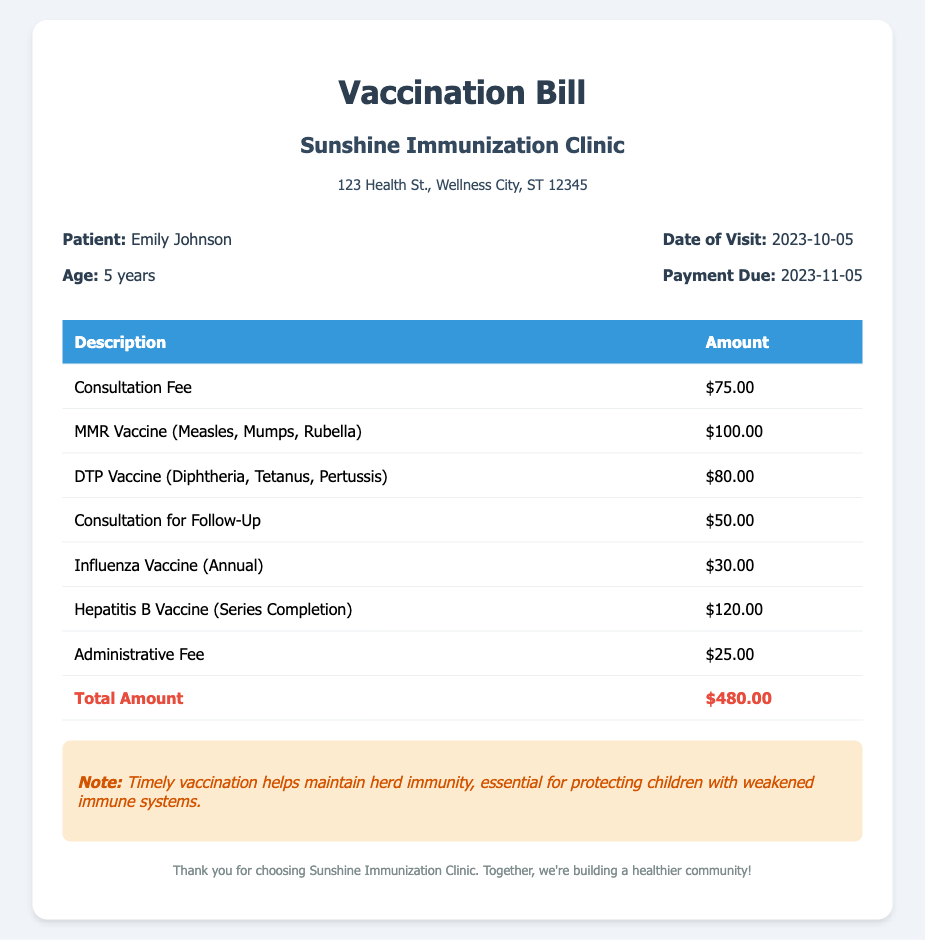What is the patient's name? The document states the patient is Emily Johnson.
Answer: Emily Johnson What is the total amount due? The final total amount listed in the bill is $480.00.
Answer: $480.00 What is the charge for the MMR vaccine? The bill indicates the charge for the MMR vaccine is $100.00.
Answer: $100.00 What is the date of the visit? The date when the visit took place is provided as 2023-10-05.
Answer: 2023-10-05 How much is charged for the administrative fee? According to the document, the administrative fee is $25.00.
Answer: $25.00 Why is timely vaccination important? The note in the document highlights that it helps maintain herd immunity, crucial for protection.
Answer: To maintain herd immunity What services are listed under consultation fees? The document specifies consultation for both initial and follow-up visits.
Answer: Consultation Fee and Consultation for Follow-Up What is the age of the patient? The document states that the age of the patient is 5 years.
Answer: 5 years What is the billing address of the clinic? The clinic's address is noted as 123 Health St., Wellness City, ST 12345.
Answer: 123 Health St., Wellness City, ST 12345 